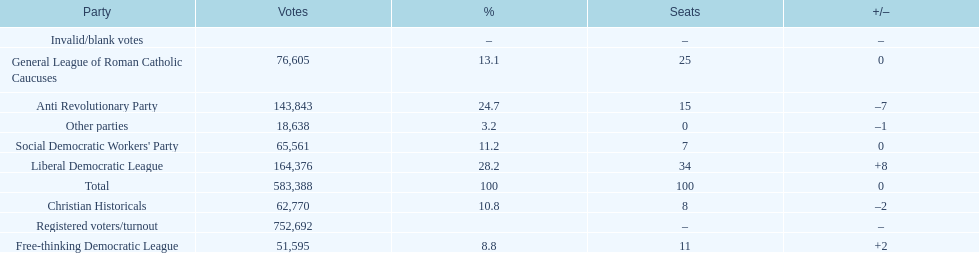After the election, how many seats did the liberal democratic league win? 34. 